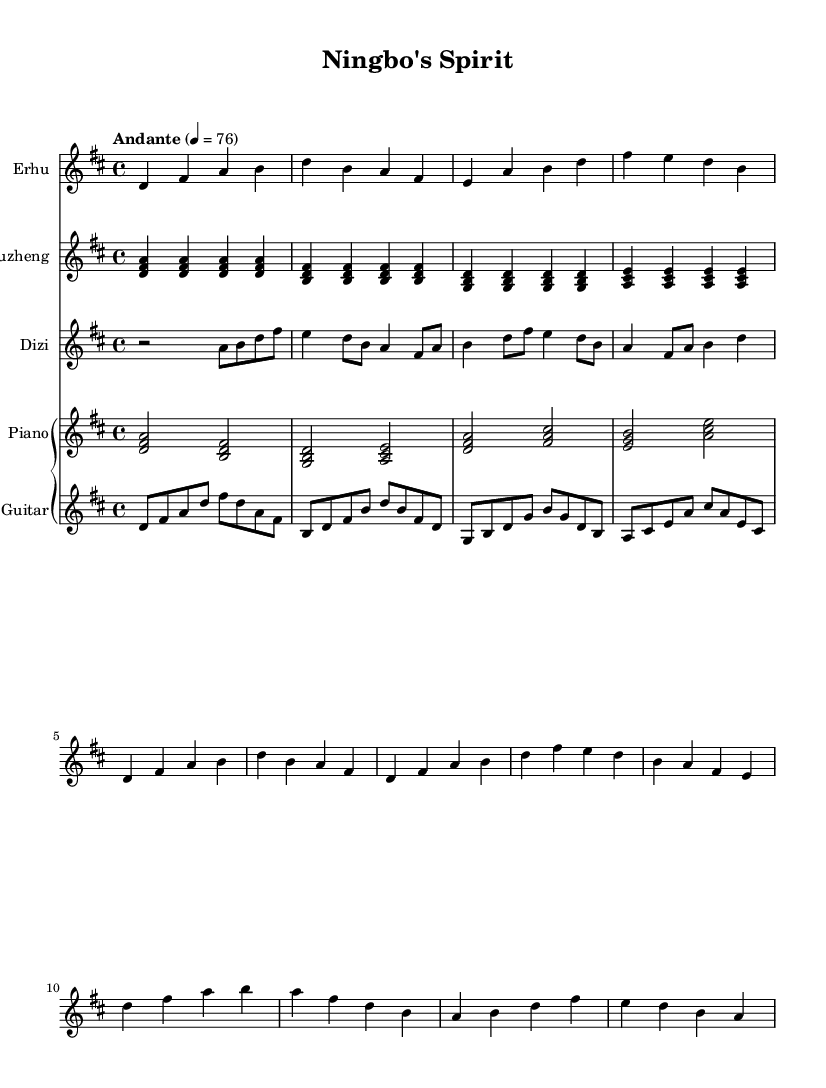What is the key signature of this music? The key signature is D major, which has two sharps: F sharp and C sharp.
Answer: D major What is the time signature of this music? The time signature is 4/4, meaning there are four beats in each measure and the quarter note gets one beat.
Answer: 4/4 What is the tempo marking of this music? The tempo marking is "Andante," which refers to a moderately slow tempo, typically around 76 beats per minute.
Answer: Andante How many staves are used for the instruments in this score? There are five staves in total, one for each instrument: Erhu, Guzheng, Dizi, Piano, and Guitar.
Answer: Five Which instrument plays the highest pitches? The Dizi plays the highest pitches in this composition as it is a bamboo flute that typically plays in higher registers compared to the other instruments.
Answer: Dizi What type of music does this score represent? This score represents traditional Chinese folk music with modern interpretations, reflecting the cultural elements of Ningbo.
Answer: Traditional Chinese folk music How many times is the note D repeated in the piano part? In the piano part, the note D appears four times in the first measure and subsequently in other measures, totaling twelve occurrences throughout the piece.
Answer: Twelve 